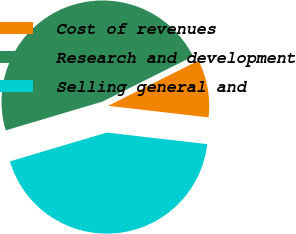Convert chart to OTSL. <chart><loc_0><loc_0><loc_500><loc_500><pie_chart><fcel>Cost of revenues<fcel>Research and development<fcel>Selling general and<nl><fcel>9.21%<fcel>47.22%<fcel>43.57%<nl></chart> 